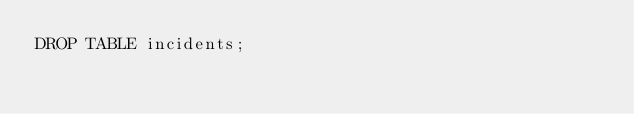<code> <loc_0><loc_0><loc_500><loc_500><_SQL_>DROP TABLE incidents;</code> 